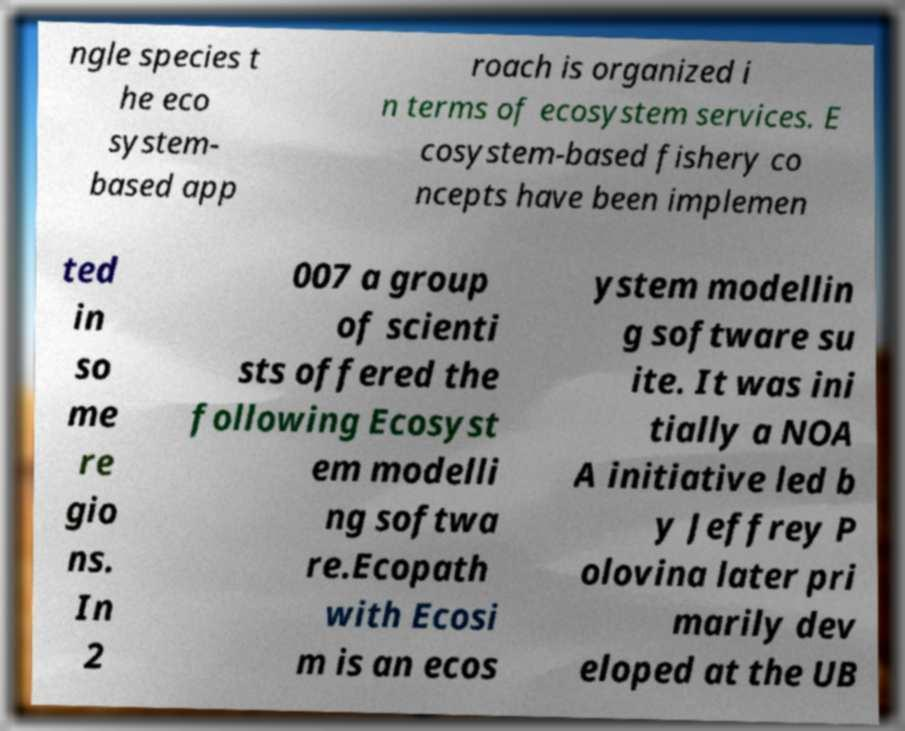For documentation purposes, I need the text within this image transcribed. Could you provide that? ngle species t he eco system- based app roach is organized i n terms of ecosystem services. E cosystem-based fishery co ncepts have been implemen ted in so me re gio ns. In 2 007 a group of scienti sts offered the following Ecosyst em modelli ng softwa re.Ecopath with Ecosi m is an ecos ystem modellin g software su ite. It was ini tially a NOA A initiative led b y Jeffrey P olovina later pri marily dev eloped at the UB 